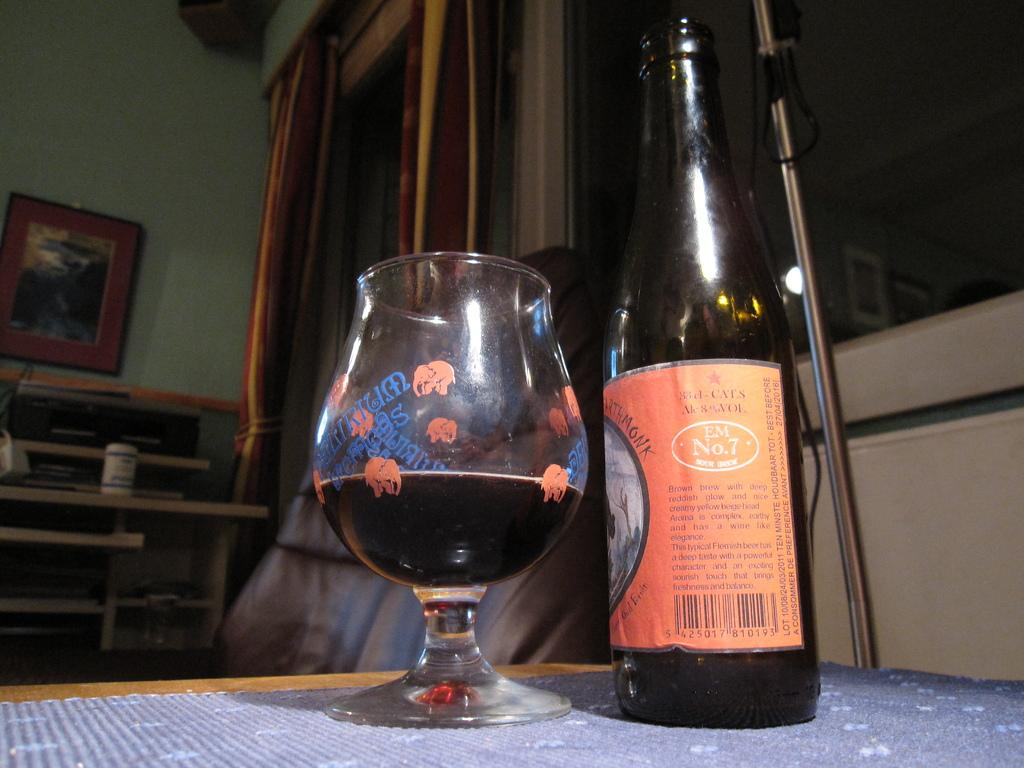What objects are on the table in the image? There is a bottle and a glass on the table in the image. What is the purpose of the chair in the image? The chair is likely for sitting, although its specific use is not clear from the image. What type of window treatment is present in the image? There are curtains associated with a window in the image. What is hanging on the wall in the image? There is a photo frame on a wall in the image. What type of seating is visible in the image? There are benches visible in the image. What type of oil is being used to lubricate the system in the image? There is no system or oil present in the image; it features a bottle, glass, chair, curtains, photo frame, and benches. What type of tail is visible on the animal in the image? There is no animal or tail present in the image. 